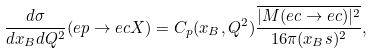Convert formula to latex. <formula><loc_0><loc_0><loc_500><loc_500>\frac { d \sigma } { d x _ { B } d Q ^ { 2 } } ( e p \to e c X ) = C _ { p } ( x _ { B } , Q ^ { 2 } ) \frac { \overline { | M ( e c \to e c ) | ^ { 2 } } } { 1 6 \pi ( x _ { B } s ) ^ { 2 } } ,</formula> 